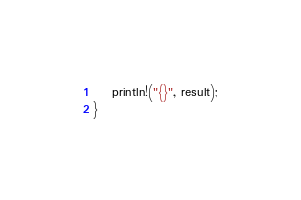<code> <loc_0><loc_0><loc_500><loc_500><_Rust_>    println!("{}", result);
}
</code> 